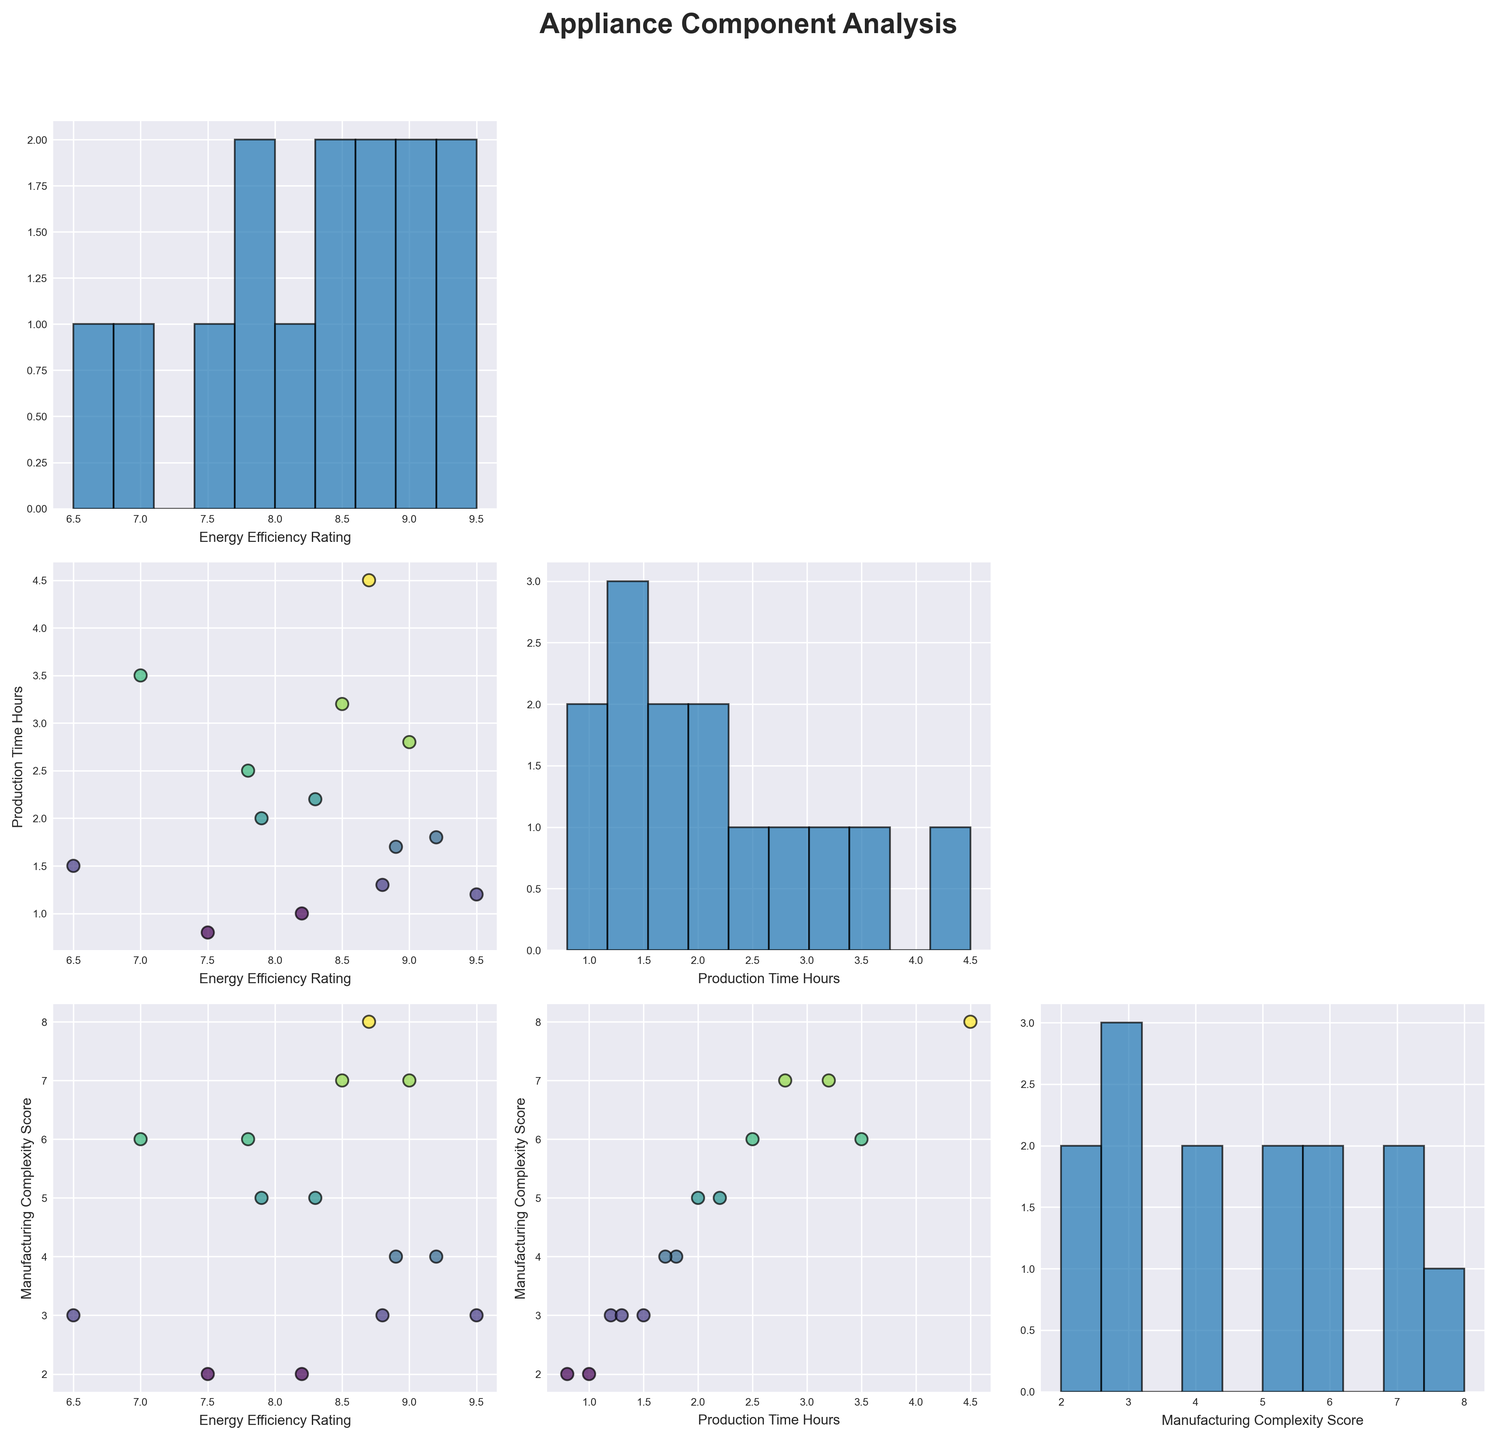What is the title of the scatterplot matrix figure? The title is generally located at the top of the figure and is designated to give an overview of what the figure represents. It typically stands out due to larger font size and may also be bold.
Answer: Appliance Component Analysis How many variables are being compared in the scatterplot matrix? Count the number of unique variables being displayed along both rows and columns of the scatterplot matrix. This can usually be understood from the labels on the axes.
Answer: 3 What is the range of the 'Energy Efficiency Rating' axis in the scatterplot matrix? Find the horizontal or vertical axis labeled as 'Energy Efficiency Rating' and examine the scale provided along this axis to determine the range.
Answer: 6.5 to 9.5 Are there more components with higher 'Energy Efficiency Rating' values or lower ones? Identify the histogram or scatter plots showcasing the distribution of 'Energy Efficiency Rating'. By visual inspection of the bins in the histogram, one can gauge the number of components with higher or lower values.
Answer: Higher values Which component has the longest production time? Look at the scatter plot or histogram that displays the 'Production Time Hours'. The highest value or the rightmost data point on this axis reveals the component with the longest production time.
Answer: Heat Exchanger Compare the 'Manufacturing Complexity Score' and 'Production Time Hours'. Which variable tends to increase as the other increases? Examine the scatter plots where these two variables intersect; follow the general trend to determine if one variable shows an upward trend as the other increases.
Answer: Manufacturing Complexity Score increases with Production Time Hours What is the common 'Manufacturing Complexity Score' for components with the highest 'Energy Efficiency Rating'? Determine from the scatter plots which 'Manufacturing Complexity Score' is shared by data points having the highest 'Energy Efficiency Rating' values. Look for clustering around specific scores.
Answer: 3 Which variable has a wider range of values: 'Energy Efficiency Rating' or 'Production Time Hours'? Compare the range of values on the axes labeled 'Energy Efficiency Rating' and 'Production Time Hours' to see which has a broader extent. The one with the greater difference between minimum and maximum marks has a wider range.
Answer: Production Time Hours Is there a component with both high 'Energy Efficiency Rating' and low 'Production Time Hours'? In the scatterplot crossing these two variables, identify data points that lie toward high 'Energy Efficiency Rating' and low 'Production Time Hours'. Check the specific names of these components.
Answer: Thermostat How does the 'Energy Efficiency Rating' distribute among components with 'Manufacturing Complexity Score' of 2? Examine the scatter plot intersecting 'Energy Efficiency Rating' and 'Manufacturing Complexity Score'. Look for data points at 'Manufacturing Complexity Score' of 2 and observe their 'Energy Efficiency Rating'.
Answer: Between 7.5 and 8.2 